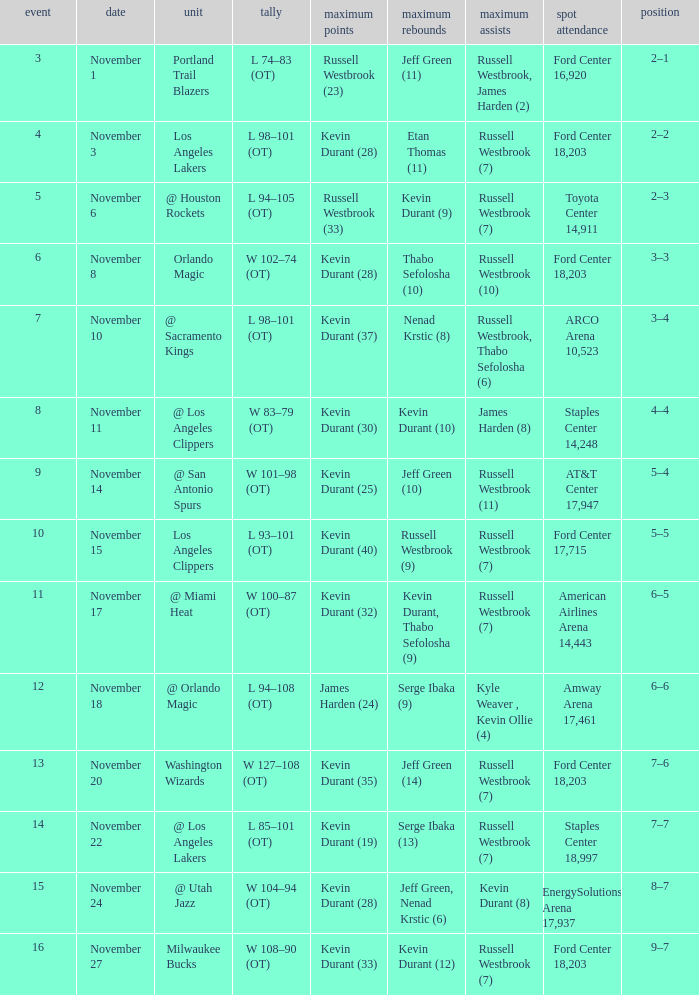When was the game number 3 played? November 1. 